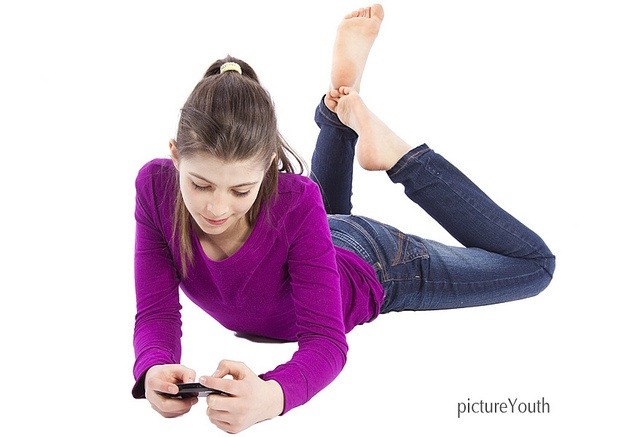Describe the objects in this image and their specific colors. I can see people in white, purple, and gray tones and cell phone in white, black, gray, maroon, and darkgray tones in this image. 